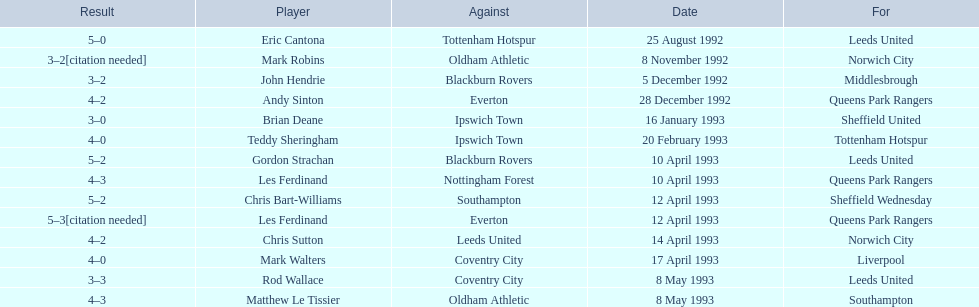Name the players for tottenham hotspur. Teddy Sheringham. 